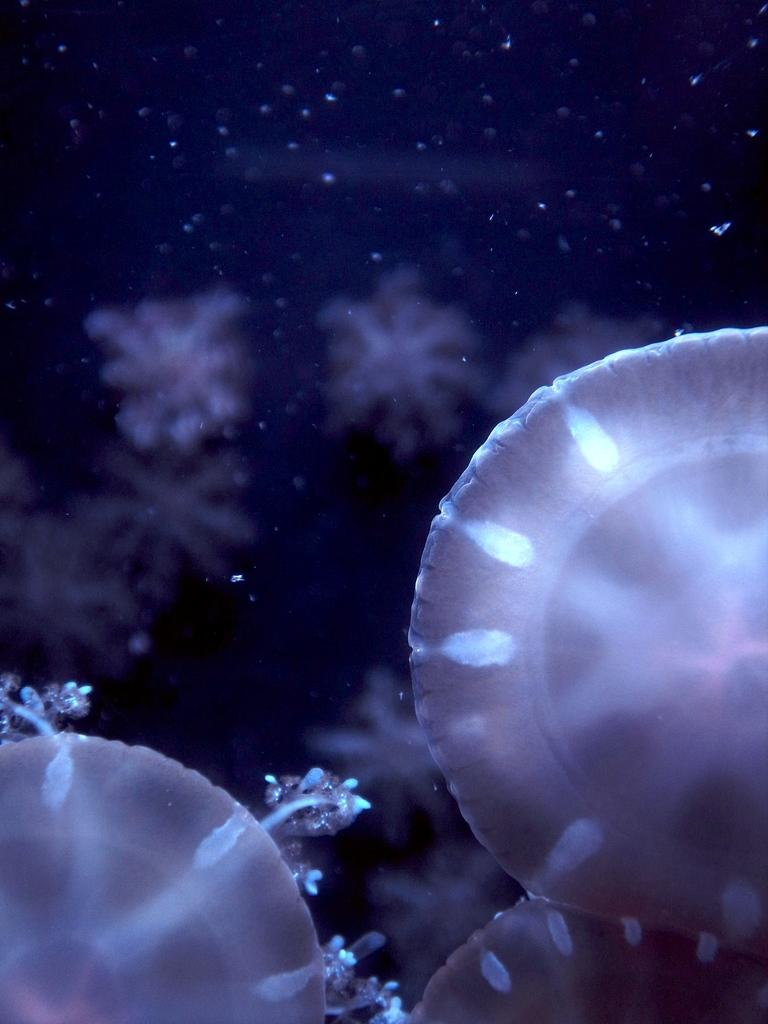What type of marine animals are in the image? There are jellyfishes in the image. Where are the jellyfishes located? The jellyfishes are in the water. What type of payment is required to enter the jar in the image? There is no jar present in the image, and therefore no payment is required. 